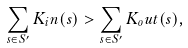Convert formula to latex. <formula><loc_0><loc_0><loc_500><loc_500>\sum _ { s \in S ^ { \prime } } K _ { i } n ( s ) > \sum _ { s \in S ^ { \prime } } K _ { o } u t ( s ) ,</formula> 